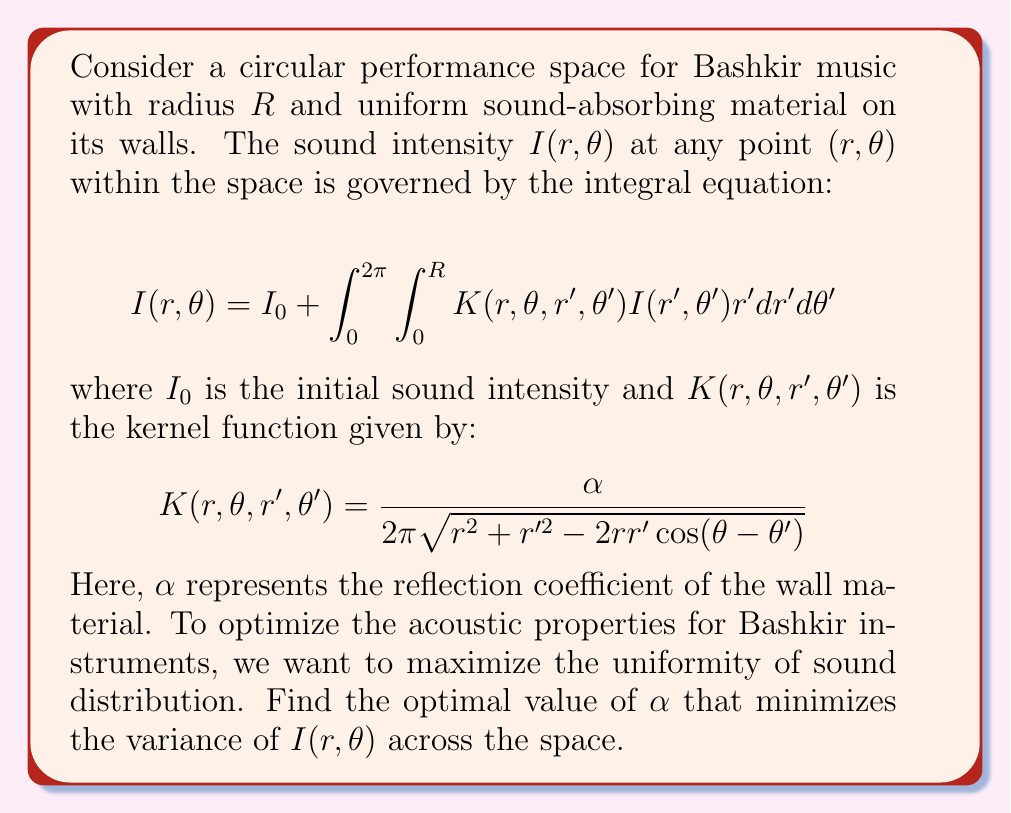Show me your answer to this math problem. To solve this problem, we'll follow these steps:

1) First, we need to discretize the integral equation to create a system of linear equations. Let's divide the circle into $N$ equal segments.

2) The discretized equation becomes:

   $$I_i = I_0 + \sum_{j=1}^N w_j K_{ij} I_j$$

   where $w_j$ are the weights for numerical integration, and $K_{ij}$ is the kernel function evaluated at discrete points.

3) This can be written in matrix form:

   $$(I - K)I = I_0 \mathbf{1}$$

   where $I$ is the identity matrix, $K$ is the matrix of $w_j K_{ij}$ values, and $\mathbf{1}$ is a vector of ones.

4) The solution for $I$ is:

   $$I = (I - K)^{-1} I_0 \mathbf{1}$$

5) To measure uniformity, we calculate the variance of $I$:

   $$\text{Var}(I) = \frac{1}{N} \sum_{i=1}^N (I_i - \bar{I})^2$$

   where $\bar{I}$ is the mean of $I$.

6) We want to find $\alpha$ that minimizes $\text{Var}(I)$. This can be done numerically using optimization techniques like gradient descent.

7) Implement a function that calculates $\text{Var}(I)$ for a given $\alpha$, then use an optimization algorithm to find the $\alpha$ that minimizes this function.

8) The optimal $\alpha$ will depend on the specific parameters of the space (like $R$ and $I_0$) and the discretization level $N$. For typical concert hall materials, $\alpha$ often falls in the range of 0.1 to 0.5.
Answer: The optimal $\alpha$ minimizes $\text{Var}(I)$ in the equation $I = (I - K)^{-1} I_0 \mathbf{1}$, where $K_{ij} = \frac{\alpha w_j}{2\pi \sqrt{r_i^2 + r_j^2 - 2r_ir_j\cos(\theta_i-\theta_j)}}$. 